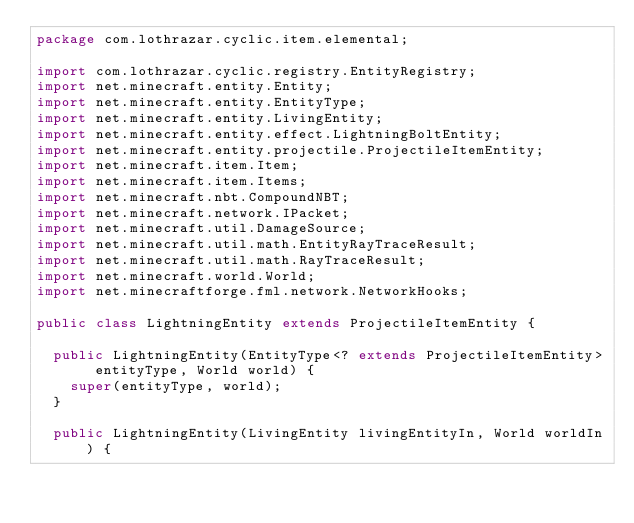<code> <loc_0><loc_0><loc_500><loc_500><_Java_>package com.lothrazar.cyclic.item.elemental;

import com.lothrazar.cyclic.registry.EntityRegistry;
import net.minecraft.entity.Entity;
import net.minecraft.entity.EntityType;
import net.minecraft.entity.LivingEntity;
import net.minecraft.entity.effect.LightningBoltEntity;
import net.minecraft.entity.projectile.ProjectileItemEntity;
import net.minecraft.item.Item;
import net.minecraft.item.Items;
import net.minecraft.nbt.CompoundNBT;
import net.minecraft.network.IPacket;
import net.minecraft.util.DamageSource;
import net.minecraft.util.math.EntityRayTraceResult;
import net.minecraft.util.math.RayTraceResult;
import net.minecraft.world.World;
import net.minecraftforge.fml.network.NetworkHooks;

public class LightningEntity extends ProjectileItemEntity {

  public LightningEntity(EntityType<? extends ProjectileItemEntity> entityType, World world) {
    super(entityType, world);
  }

  public LightningEntity(LivingEntity livingEntityIn, World worldIn) {</code> 